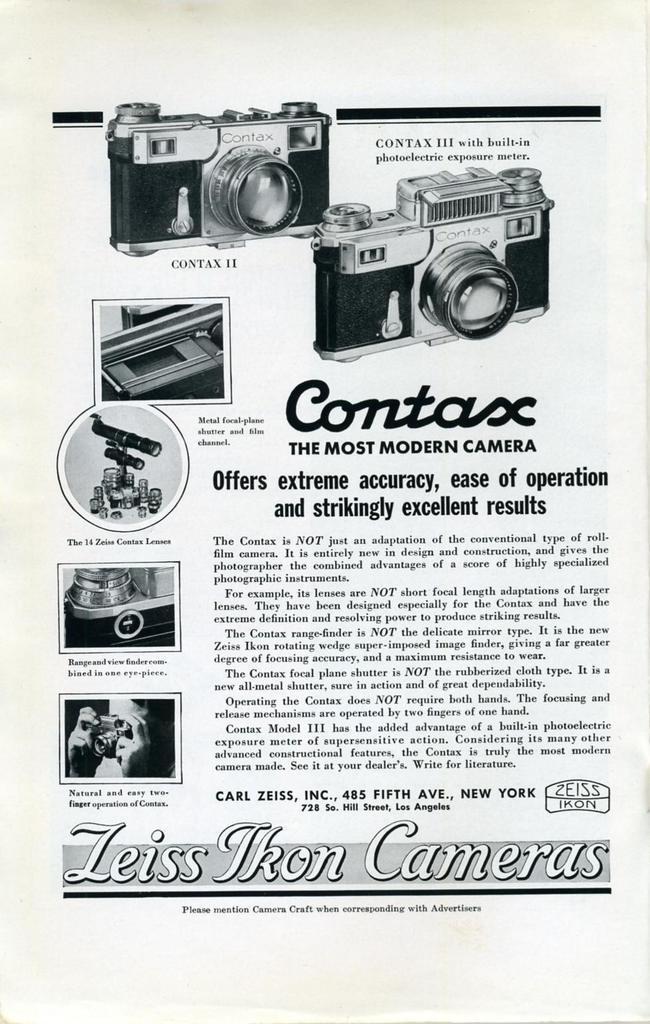In one or two sentences, can you explain what this image depicts? This is a paper and here we can see some text and cameras and some other objects. 